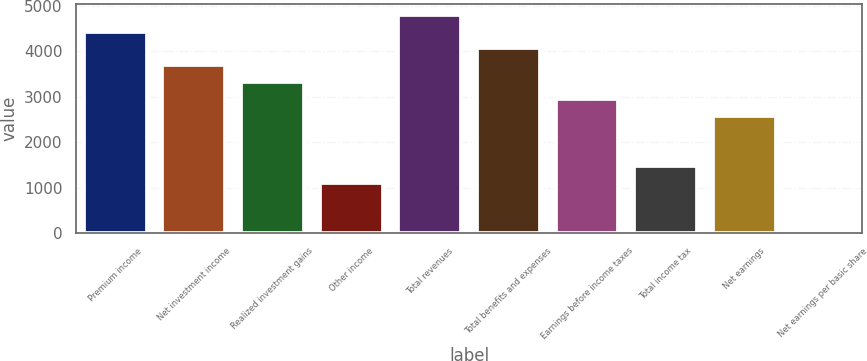Convert chart to OTSL. <chart><loc_0><loc_0><loc_500><loc_500><bar_chart><fcel>Premium income<fcel>Net investment income<fcel>Realized investment gains<fcel>Other income<fcel>Total revenues<fcel>Total benefits and expenses<fcel>Earnings before income taxes<fcel>Total income tax<fcel>Net earnings<fcel>Net earnings per basic share<nl><fcel>4429.17<fcel>3691.01<fcel>3321.93<fcel>1107.45<fcel>4798.25<fcel>4060.09<fcel>2952.85<fcel>1476.53<fcel>2583.77<fcel>0.21<nl></chart> 